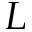Convert formula to latex. <formula><loc_0><loc_0><loc_500><loc_500>L</formula> 